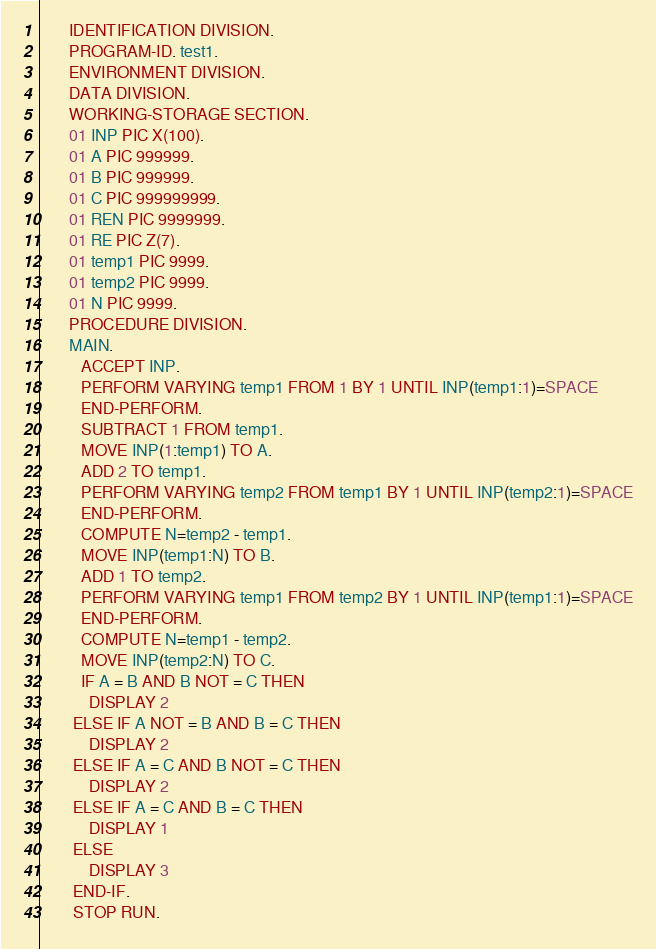Convert code to text. <code><loc_0><loc_0><loc_500><loc_500><_COBOL_>       IDENTIFICATION DIVISION.
       PROGRAM-ID. test1.
       ENVIRONMENT DIVISION.
       DATA DIVISION.
       WORKING-STORAGE SECTION.
       01 INP PIC X(100).
       01 A PIC 999999.
       01 B PIC 999999.
       01 C PIC 999999999.
       01 REN PIC 9999999.
       01 RE PIC Z(7).
       01 temp1 PIC 9999.
       01 temp2 PIC 9999.
       01 N PIC 9999.
       PROCEDURE DIVISION.
       MAIN.
       	ACCEPT INP.
      	PERFORM VARYING temp1 FROM 1 BY 1 UNTIL INP(temp1:1)=SPACE
      	END-PERFORM.
      	SUBTRACT 1 FROM temp1.
      	MOVE INP(1:temp1) TO A.
      	ADD 2 TO temp1.
      	PERFORM VARYING temp2 FROM temp1 BY 1 UNTIL INP(temp2:1)=SPACE
      	END-PERFORM.
      	COMPUTE N=temp2 - temp1.
      	MOVE INP(temp1:N) TO B.
      	ADD 1 TO temp2.
      	PERFORM VARYING temp1 FROM temp2 BY 1 UNTIL INP(temp1:1)=SPACE
      	END-PERFORM.
      	COMPUTE N=temp1 - temp2.
      	MOVE INP(temp2:N) TO C.
      	IF A = B AND B NOT = C THEN
      		DISPLAY 2
      	ELSE IF A NOT = B AND B = C THEN
      		DISPLAY 2
      	ELSE IF A = C AND B NOT = C THEN
      		DISPLAY 2
      	ELSE IF A = C AND B = C THEN
      		DISPLAY 1
      	ELSE 
      		DISPLAY 3
      	END-IF.
        STOP RUN.
</code> 